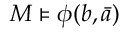Convert formula to latex. <formula><loc_0><loc_0><loc_500><loc_500>M \vDash \phi ( b , { \bar { a } } )</formula> 